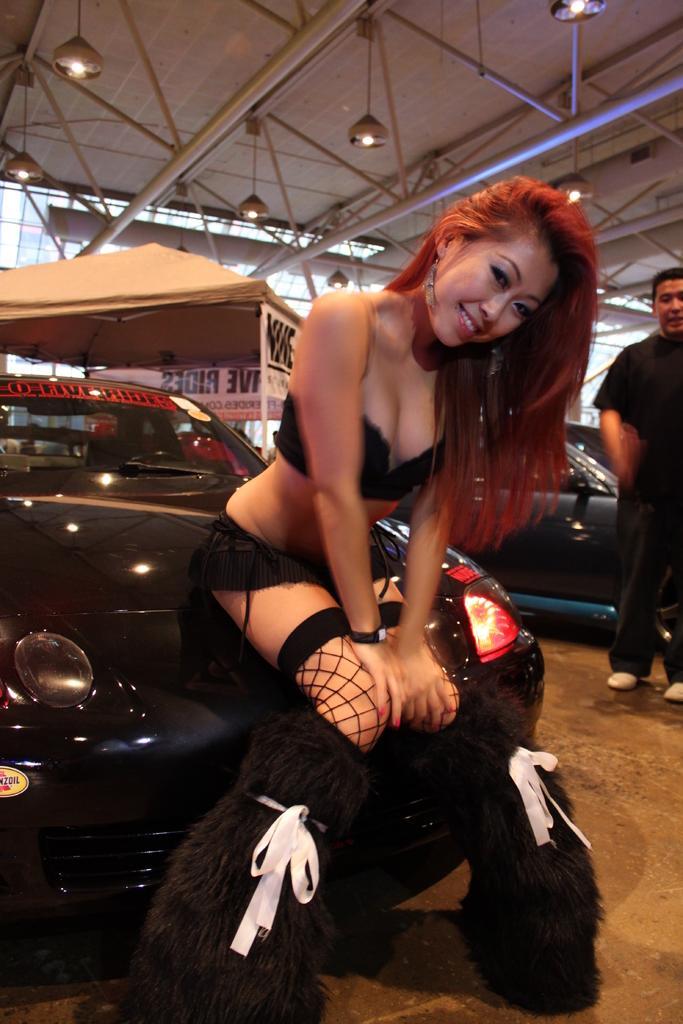Can you describe this image briefly? In this picture there is a woman sitting on a car behind her and there is a person standing in the right corner and there is a vehicle behind him and there are few lights and some other objects in the background. 